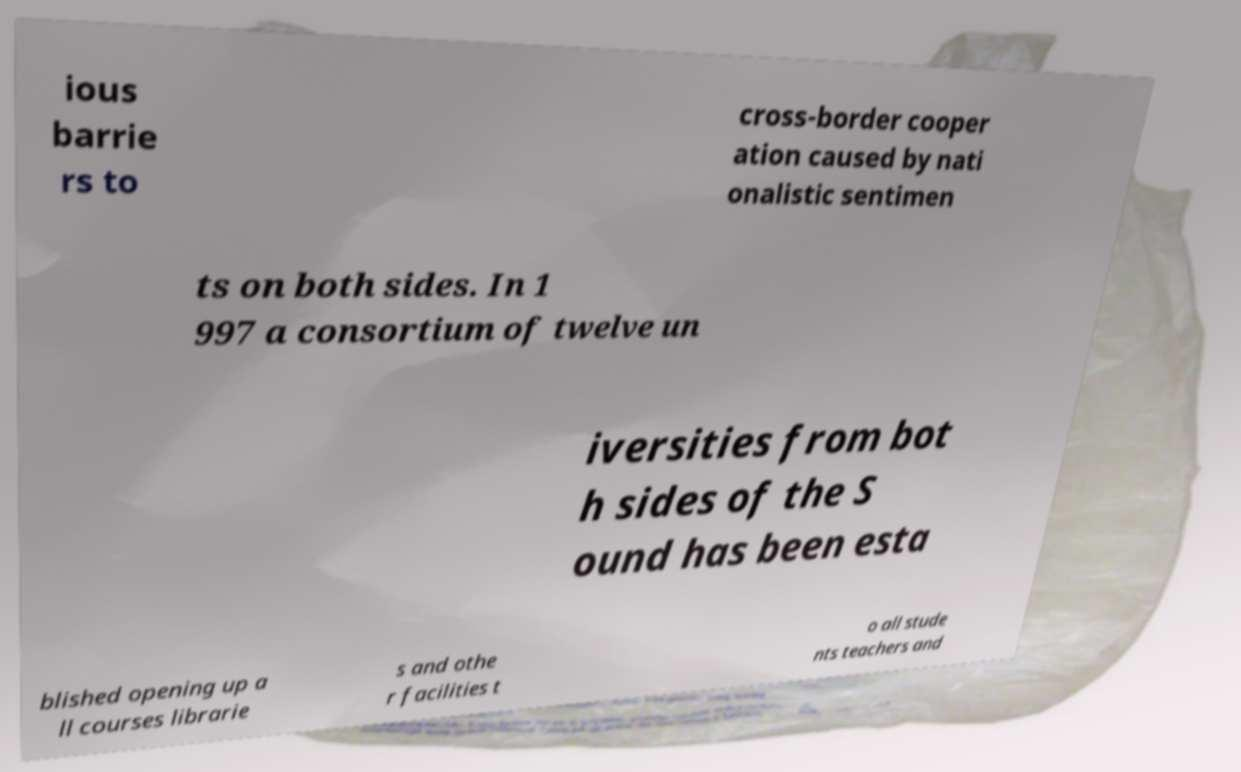There's text embedded in this image that I need extracted. Can you transcribe it verbatim? ious barrie rs to cross-border cooper ation caused by nati onalistic sentimen ts on both sides. In 1 997 a consortium of twelve un iversities from bot h sides of the S ound has been esta blished opening up a ll courses librarie s and othe r facilities t o all stude nts teachers and 